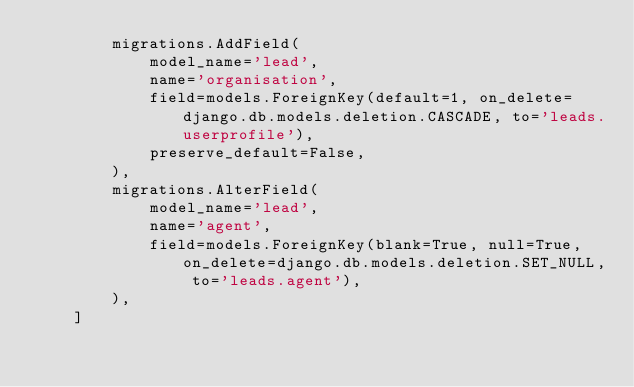<code> <loc_0><loc_0><loc_500><loc_500><_Python_>        migrations.AddField(
            model_name='lead',
            name='organisation',
            field=models.ForeignKey(default=1, on_delete=django.db.models.deletion.CASCADE, to='leads.userprofile'),
            preserve_default=False,
        ),
        migrations.AlterField(
            model_name='lead',
            name='agent',
            field=models.ForeignKey(blank=True, null=True, on_delete=django.db.models.deletion.SET_NULL, to='leads.agent'),
        ),
    ]
</code> 